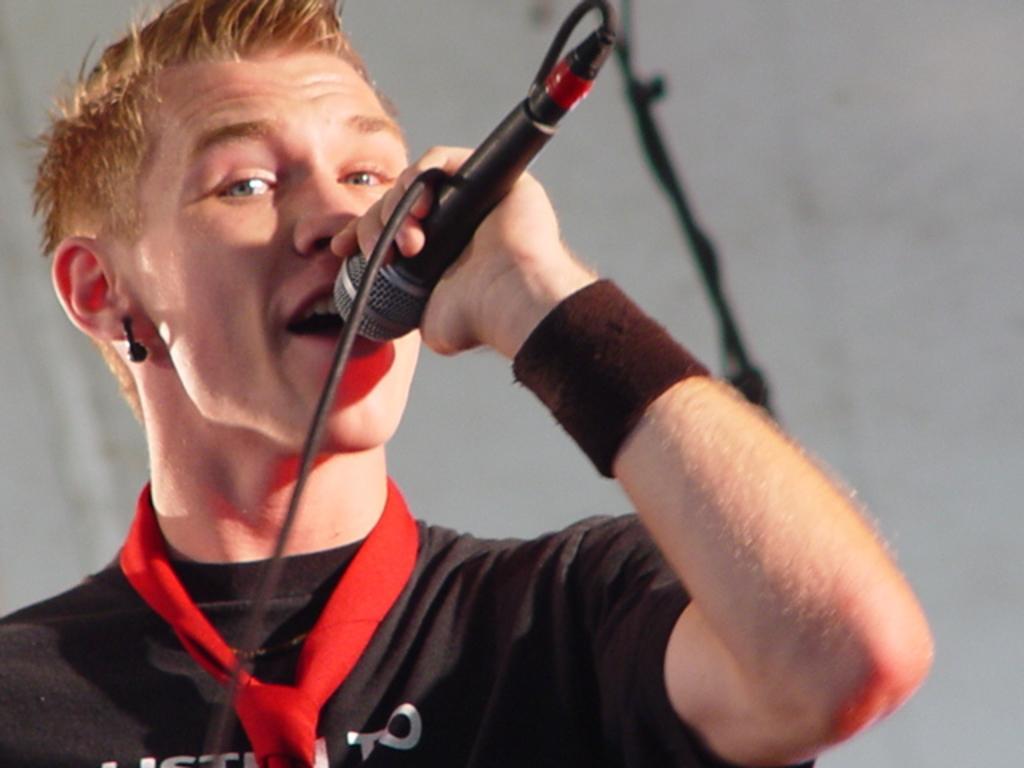Please provide a concise description of this image. This is the man holding a mike and singing a song. This looks like a wire, which is attached to the mike. He wore a tie, T-shirt and an earring. 